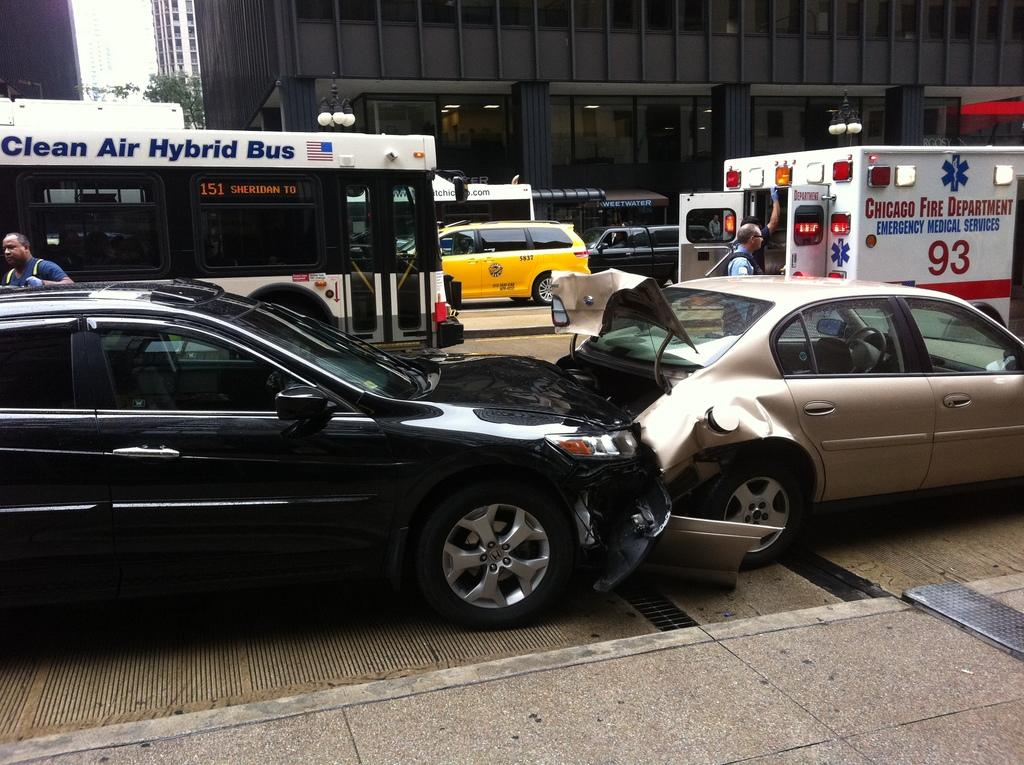<image>
Write a terse but informative summary of the picture. A car was rearended and a Chicago ambulance with number 93 on it is there. 